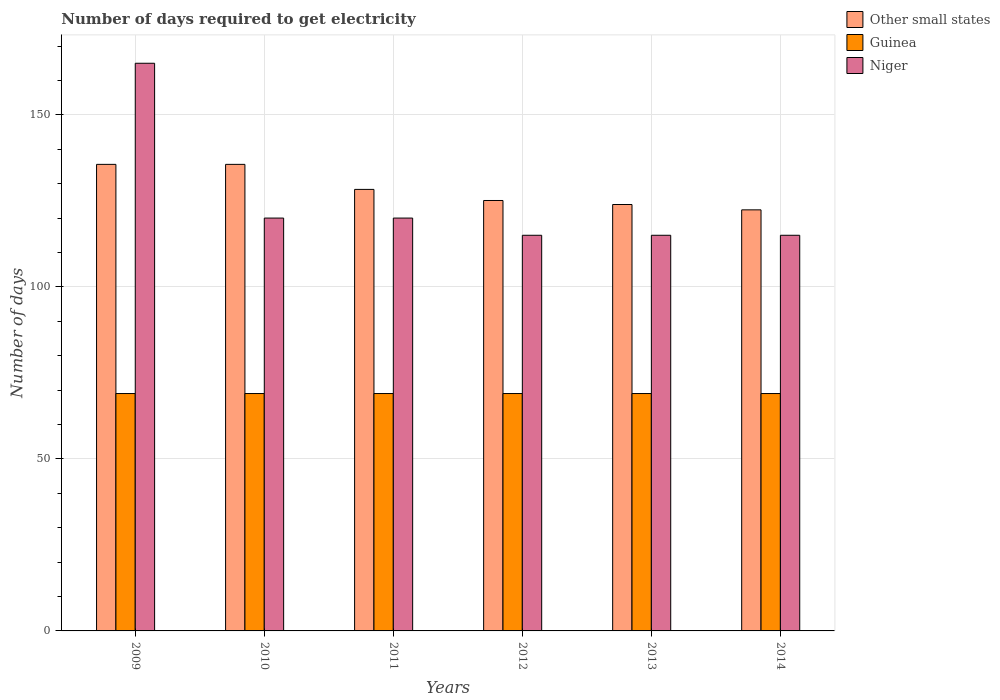How many groups of bars are there?
Ensure brevity in your answer.  6. Are the number of bars per tick equal to the number of legend labels?
Make the answer very short. Yes. How many bars are there on the 2nd tick from the left?
Your response must be concise. 3. In how many cases, is the number of bars for a given year not equal to the number of legend labels?
Offer a terse response. 0. What is the number of days required to get electricity in in Other small states in 2013?
Make the answer very short. 123.94. Across all years, what is the maximum number of days required to get electricity in in Guinea?
Provide a succinct answer. 69. Across all years, what is the minimum number of days required to get electricity in in Guinea?
Offer a very short reply. 69. What is the total number of days required to get electricity in in Niger in the graph?
Make the answer very short. 750. What is the difference between the number of days required to get electricity in in Other small states in 2010 and that in 2012?
Offer a terse response. 10.5. What is the difference between the number of days required to get electricity in in Guinea in 2010 and the number of days required to get electricity in in Other small states in 2012?
Your answer should be very brief. -56.11. What is the average number of days required to get electricity in in Niger per year?
Provide a short and direct response. 125. In the year 2014, what is the difference between the number of days required to get electricity in in Guinea and number of days required to get electricity in in Other small states?
Ensure brevity in your answer.  -53.39. Is the number of days required to get electricity in in Other small states in 2009 less than that in 2013?
Give a very brief answer. No. What is the difference between the highest and the lowest number of days required to get electricity in in Other small states?
Your response must be concise. 13.22. Is the sum of the number of days required to get electricity in in Guinea in 2012 and 2013 greater than the maximum number of days required to get electricity in in Other small states across all years?
Keep it short and to the point. Yes. What does the 1st bar from the left in 2011 represents?
Keep it short and to the point. Other small states. What does the 2nd bar from the right in 2012 represents?
Offer a terse response. Guinea. How many bars are there?
Your response must be concise. 18. Are all the bars in the graph horizontal?
Your answer should be very brief. No. How many years are there in the graph?
Your answer should be compact. 6. Does the graph contain grids?
Your response must be concise. Yes. How many legend labels are there?
Keep it short and to the point. 3. What is the title of the graph?
Make the answer very short. Number of days required to get electricity. Does "Eritrea" appear as one of the legend labels in the graph?
Offer a very short reply. No. What is the label or title of the Y-axis?
Make the answer very short. Number of days. What is the Number of days of Other small states in 2009?
Your answer should be compact. 135.61. What is the Number of days in Guinea in 2009?
Keep it short and to the point. 69. What is the Number of days of Niger in 2009?
Give a very brief answer. 165. What is the Number of days in Other small states in 2010?
Your answer should be compact. 135.61. What is the Number of days in Niger in 2010?
Provide a short and direct response. 120. What is the Number of days in Other small states in 2011?
Make the answer very short. 128.33. What is the Number of days of Niger in 2011?
Provide a short and direct response. 120. What is the Number of days of Other small states in 2012?
Offer a very short reply. 125.11. What is the Number of days in Niger in 2012?
Offer a terse response. 115. What is the Number of days in Other small states in 2013?
Your response must be concise. 123.94. What is the Number of days in Guinea in 2013?
Offer a terse response. 69. What is the Number of days in Niger in 2013?
Your answer should be very brief. 115. What is the Number of days of Other small states in 2014?
Offer a terse response. 122.39. What is the Number of days in Guinea in 2014?
Your answer should be very brief. 69. What is the Number of days of Niger in 2014?
Provide a short and direct response. 115. Across all years, what is the maximum Number of days of Other small states?
Make the answer very short. 135.61. Across all years, what is the maximum Number of days of Niger?
Make the answer very short. 165. Across all years, what is the minimum Number of days of Other small states?
Provide a short and direct response. 122.39. Across all years, what is the minimum Number of days in Niger?
Offer a very short reply. 115. What is the total Number of days in Other small states in the graph?
Your answer should be very brief. 771. What is the total Number of days in Guinea in the graph?
Give a very brief answer. 414. What is the total Number of days of Niger in the graph?
Ensure brevity in your answer.  750. What is the difference between the Number of days of Guinea in 2009 and that in 2010?
Give a very brief answer. 0. What is the difference between the Number of days of Niger in 2009 and that in 2010?
Your response must be concise. 45. What is the difference between the Number of days in Other small states in 2009 and that in 2011?
Your response must be concise. 7.28. What is the difference between the Number of days of Niger in 2009 and that in 2011?
Make the answer very short. 45. What is the difference between the Number of days of Other small states in 2009 and that in 2012?
Your response must be concise. 10.5. What is the difference between the Number of days of Other small states in 2009 and that in 2013?
Give a very brief answer. 11.67. What is the difference between the Number of days of Guinea in 2009 and that in 2013?
Your answer should be very brief. 0. What is the difference between the Number of days in Niger in 2009 and that in 2013?
Your answer should be very brief. 50. What is the difference between the Number of days of Other small states in 2009 and that in 2014?
Ensure brevity in your answer.  13.22. What is the difference between the Number of days of Other small states in 2010 and that in 2011?
Ensure brevity in your answer.  7.28. What is the difference between the Number of days in Niger in 2010 and that in 2012?
Your answer should be very brief. 5. What is the difference between the Number of days of Other small states in 2010 and that in 2013?
Your answer should be compact. 11.67. What is the difference between the Number of days of Other small states in 2010 and that in 2014?
Your response must be concise. 13.22. What is the difference between the Number of days in Guinea in 2010 and that in 2014?
Keep it short and to the point. 0. What is the difference between the Number of days of Other small states in 2011 and that in 2012?
Offer a very short reply. 3.22. What is the difference between the Number of days in Other small states in 2011 and that in 2013?
Make the answer very short. 4.39. What is the difference between the Number of days in Guinea in 2011 and that in 2013?
Your response must be concise. 0. What is the difference between the Number of days in Other small states in 2011 and that in 2014?
Offer a very short reply. 5.94. What is the difference between the Number of days in Guinea in 2011 and that in 2014?
Your answer should be very brief. 0. What is the difference between the Number of days in Niger in 2012 and that in 2013?
Offer a terse response. 0. What is the difference between the Number of days in Other small states in 2012 and that in 2014?
Offer a very short reply. 2.72. What is the difference between the Number of days in Guinea in 2012 and that in 2014?
Provide a succinct answer. 0. What is the difference between the Number of days of Other small states in 2013 and that in 2014?
Offer a terse response. 1.56. What is the difference between the Number of days in Guinea in 2013 and that in 2014?
Provide a succinct answer. 0. What is the difference between the Number of days in Other small states in 2009 and the Number of days in Guinea in 2010?
Give a very brief answer. 66.61. What is the difference between the Number of days of Other small states in 2009 and the Number of days of Niger in 2010?
Make the answer very short. 15.61. What is the difference between the Number of days of Guinea in 2009 and the Number of days of Niger in 2010?
Ensure brevity in your answer.  -51. What is the difference between the Number of days of Other small states in 2009 and the Number of days of Guinea in 2011?
Give a very brief answer. 66.61. What is the difference between the Number of days in Other small states in 2009 and the Number of days in Niger in 2011?
Your answer should be compact. 15.61. What is the difference between the Number of days of Guinea in 2009 and the Number of days of Niger in 2011?
Your answer should be very brief. -51. What is the difference between the Number of days in Other small states in 2009 and the Number of days in Guinea in 2012?
Ensure brevity in your answer.  66.61. What is the difference between the Number of days of Other small states in 2009 and the Number of days of Niger in 2012?
Offer a very short reply. 20.61. What is the difference between the Number of days in Guinea in 2009 and the Number of days in Niger in 2012?
Provide a succinct answer. -46. What is the difference between the Number of days of Other small states in 2009 and the Number of days of Guinea in 2013?
Provide a short and direct response. 66.61. What is the difference between the Number of days in Other small states in 2009 and the Number of days in Niger in 2013?
Keep it short and to the point. 20.61. What is the difference between the Number of days of Guinea in 2009 and the Number of days of Niger in 2013?
Your response must be concise. -46. What is the difference between the Number of days in Other small states in 2009 and the Number of days in Guinea in 2014?
Provide a short and direct response. 66.61. What is the difference between the Number of days of Other small states in 2009 and the Number of days of Niger in 2014?
Provide a succinct answer. 20.61. What is the difference between the Number of days in Guinea in 2009 and the Number of days in Niger in 2014?
Offer a terse response. -46. What is the difference between the Number of days in Other small states in 2010 and the Number of days in Guinea in 2011?
Provide a succinct answer. 66.61. What is the difference between the Number of days of Other small states in 2010 and the Number of days of Niger in 2011?
Your response must be concise. 15.61. What is the difference between the Number of days in Guinea in 2010 and the Number of days in Niger in 2011?
Your response must be concise. -51. What is the difference between the Number of days of Other small states in 2010 and the Number of days of Guinea in 2012?
Provide a short and direct response. 66.61. What is the difference between the Number of days of Other small states in 2010 and the Number of days of Niger in 2012?
Provide a short and direct response. 20.61. What is the difference between the Number of days of Guinea in 2010 and the Number of days of Niger in 2012?
Ensure brevity in your answer.  -46. What is the difference between the Number of days of Other small states in 2010 and the Number of days of Guinea in 2013?
Your response must be concise. 66.61. What is the difference between the Number of days of Other small states in 2010 and the Number of days of Niger in 2013?
Make the answer very short. 20.61. What is the difference between the Number of days in Guinea in 2010 and the Number of days in Niger in 2013?
Your response must be concise. -46. What is the difference between the Number of days in Other small states in 2010 and the Number of days in Guinea in 2014?
Your answer should be very brief. 66.61. What is the difference between the Number of days of Other small states in 2010 and the Number of days of Niger in 2014?
Offer a very short reply. 20.61. What is the difference between the Number of days of Guinea in 2010 and the Number of days of Niger in 2014?
Keep it short and to the point. -46. What is the difference between the Number of days in Other small states in 2011 and the Number of days in Guinea in 2012?
Ensure brevity in your answer.  59.33. What is the difference between the Number of days in Other small states in 2011 and the Number of days in Niger in 2012?
Provide a short and direct response. 13.33. What is the difference between the Number of days of Guinea in 2011 and the Number of days of Niger in 2012?
Provide a succinct answer. -46. What is the difference between the Number of days of Other small states in 2011 and the Number of days of Guinea in 2013?
Ensure brevity in your answer.  59.33. What is the difference between the Number of days of Other small states in 2011 and the Number of days of Niger in 2013?
Keep it short and to the point. 13.33. What is the difference between the Number of days of Guinea in 2011 and the Number of days of Niger in 2013?
Your response must be concise. -46. What is the difference between the Number of days of Other small states in 2011 and the Number of days of Guinea in 2014?
Your response must be concise. 59.33. What is the difference between the Number of days in Other small states in 2011 and the Number of days in Niger in 2014?
Give a very brief answer. 13.33. What is the difference between the Number of days in Guinea in 2011 and the Number of days in Niger in 2014?
Provide a succinct answer. -46. What is the difference between the Number of days of Other small states in 2012 and the Number of days of Guinea in 2013?
Your answer should be compact. 56.11. What is the difference between the Number of days in Other small states in 2012 and the Number of days in Niger in 2013?
Ensure brevity in your answer.  10.11. What is the difference between the Number of days of Guinea in 2012 and the Number of days of Niger in 2013?
Make the answer very short. -46. What is the difference between the Number of days in Other small states in 2012 and the Number of days in Guinea in 2014?
Offer a very short reply. 56.11. What is the difference between the Number of days in Other small states in 2012 and the Number of days in Niger in 2014?
Provide a short and direct response. 10.11. What is the difference between the Number of days in Guinea in 2012 and the Number of days in Niger in 2014?
Give a very brief answer. -46. What is the difference between the Number of days in Other small states in 2013 and the Number of days in Guinea in 2014?
Your answer should be very brief. 54.94. What is the difference between the Number of days in Other small states in 2013 and the Number of days in Niger in 2014?
Offer a very short reply. 8.94. What is the difference between the Number of days of Guinea in 2013 and the Number of days of Niger in 2014?
Offer a terse response. -46. What is the average Number of days of Other small states per year?
Provide a short and direct response. 128.5. What is the average Number of days in Niger per year?
Your answer should be very brief. 125. In the year 2009, what is the difference between the Number of days of Other small states and Number of days of Guinea?
Ensure brevity in your answer.  66.61. In the year 2009, what is the difference between the Number of days in Other small states and Number of days in Niger?
Your response must be concise. -29.39. In the year 2009, what is the difference between the Number of days of Guinea and Number of days of Niger?
Provide a succinct answer. -96. In the year 2010, what is the difference between the Number of days of Other small states and Number of days of Guinea?
Provide a succinct answer. 66.61. In the year 2010, what is the difference between the Number of days in Other small states and Number of days in Niger?
Your response must be concise. 15.61. In the year 2010, what is the difference between the Number of days of Guinea and Number of days of Niger?
Offer a terse response. -51. In the year 2011, what is the difference between the Number of days of Other small states and Number of days of Guinea?
Your answer should be compact. 59.33. In the year 2011, what is the difference between the Number of days in Other small states and Number of days in Niger?
Ensure brevity in your answer.  8.33. In the year 2011, what is the difference between the Number of days in Guinea and Number of days in Niger?
Make the answer very short. -51. In the year 2012, what is the difference between the Number of days of Other small states and Number of days of Guinea?
Give a very brief answer. 56.11. In the year 2012, what is the difference between the Number of days of Other small states and Number of days of Niger?
Ensure brevity in your answer.  10.11. In the year 2012, what is the difference between the Number of days of Guinea and Number of days of Niger?
Offer a terse response. -46. In the year 2013, what is the difference between the Number of days of Other small states and Number of days of Guinea?
Give a very brief answer. 54.94. In the year 2013, what is the difference between the Number of days of Other small states and Number of days of Niger?
Offer a terse response. 8.94. In the year 2013, what is the difference between the Number of days of Guinea and Number of days of Niger?
Ensure brevity in your answer.  -46. In the year 2014, what is the difference between the Number of days of Other small states and Number of days of Guinea?
Offer a terse response. 53.39. In the year 2014, what is the difference between the Number of days of Other small states and Number of days of Niger?
Provide a short and direct response. 7.39. In the year 2014, what is the difference between the Number of days in Guinea and Number of days in Niger?
Keep it short and to the point. -46. What is the ratio of the Number of days of Other small states in 2009 to that in 2010?
Make the answer very short. 1. What is the ratio of the Number of days of Niger in 2009 to that in 2010?
Ensure brevity in your answer.  1.38. What is the ratio of the Number of days of Other small states in 2009 to that in 2011?
Offer a terse response. 1.06. What is the ratio of the Number of days in Guinea in 2009 to that in 2011?
Your answer should be very brief. 1. What is the ratio of the Number of days in Niger in 2009 to that in 2011?
Provide a succinct answer. 1.38. What is the ratio of the Number of days of Other small states in 2009 to that in 2012?
Make the answer very short. 1.08. What is the ratio of the Number of days of Niger in 2009 to that in 2012?
Provide a short and direct response. 1.43. What is the ratio of the Number of days in Other small states in 2009 to that in 2013?
Offer a terse response. 1.09. What is the ratio of the Number of days in Niger in 2009 to that in 2013?
Make the answer very short. 1.43. What is the ratio of the Number of days in Other small states in 2009 to that in 2014?
Your response must be concise. 1.11. What is the ratio of the Number of days in Guinea in 2009 to that in 2014?
Your answer should be compact. 1. What is the ratio of the Number of days in Niger in 2009 to that in 2014?
Provide a succinct answer. 1.43. What is the ratio of the Number of days of Other small states in 2010 to that in 2011?
Provide a succinct answer. 1.06. What is the ratio of the Number of days in Guinea in 2010 to that in 2011?
Provide a succinct answer. 1. What is the ratio of the Number of days of Other small states in 2010 to that in 2012?
Ensure brevity in your answer.  1.08. What is the ratio of the Number of days in Guinea in 2010 to that in 2012?
Offer a very short reply. 1. What is the ratio of the Number of days in Niger in 2010 to that in 2012?
Provide a short and direct response. 1.04. What is the ratio of the Number of days of Other small states in 2010 to that in 2013?
Give a very brief answer. 1.09. What is the ratio of the Number of days of Niger in 2010 to that in 2013?
Keep it short and to the point. 1.04. What is the ratio of the Number of days in Other small states in 2010 to that in 2014?
Provide a short and direct response. 1.11. What is the ratio of the Number of days in Guinea in 2010 to that in 2014?
Offer a terse response. 1. What is the ratio of the Number of days of Niger in 2010 to that in 2014?
Keep it short and to the point. 1.04. What is the ratio of the Number of days in Other small states in 2011 to that in 2012?
Offer a terse response. 1.03. What is the ratio of the Number of days of Niger in 2011 to that in 2012?
Keep it short and to the point. 1.04. What is the ratio of the Number of days in Other small states in 2011 to that in 2013?
Your response must be concise. 1.04. What is the ratio of the Number of days of Niger in 2011 to that in 2013?
Offer a terse response. 1.04. What is the ratio of the Number of days of Other small states in 2011 to that in 2014?
Offer a very short reply. 1.05. What is the ratio of the Number of days in Niger in 2011 to that in 2014?
Make the answer very short. 1.04. What is the ratio of the Number of days in Other small states in 2012 to that in 2013?
Your response must be concise. 1.01. What is the ratio of the Number of days of Guinea in 2012 to that in 2013?
Your answer should be compact. 1. What is the ratio of the Number of days of Niger in 2012 to that in 2013?
Provide a short and direct response. 1. What is the ratio of the Number of days of Other small states in 2012 to that in 2014?
Offer a terse response. 1.02. What is the ratio of the Number of days in Niger in 2012 to that in 2014?
Offer a terse response. 1. What is the ratio of the Number of days in Other small states in 2013 to that in 2014?
Your answer should be compact. 1.01. What is the difference between the highest and the second highest Number of days in Niger?
Offer a very short reply. 45. What is the difference between the highest and the lowest Number of days in Other small states?
Offer a very short reply. 13.22. What is the difference between the highest and the lowest Number of days in Guinea?
Your answer should be compact. 0. 